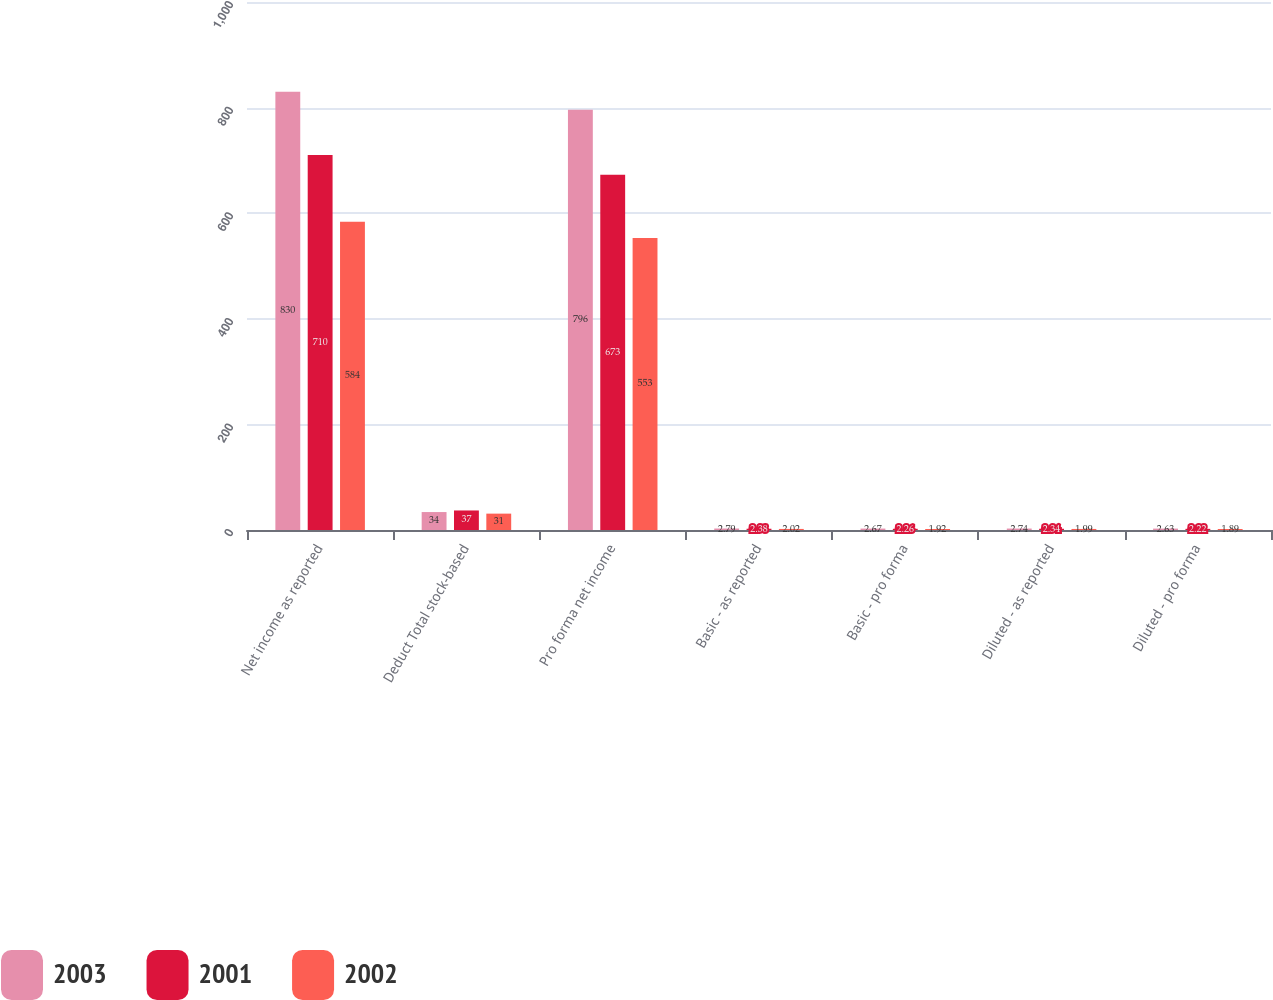Convert chart to OTSL. <chart><loc_0><loc_0><loc_500><loc_500><stacked_bar_chart><ecel><fcel>Net income as reported<fcel>Deduct Total stock-based<fcel>Pro forma net income<fcel>Basic - as reported<fcel>Basic - pro forma<fcel>Diluted - as reported<fcel>Diluted - pro forma<nl><fcel>2003<fcel>830<fcel>34<fcel>796<fcel>2.79<fcel>2.67<fcel>2.74<fcel>2.63<nl><fcel>2001<fcel>710<fcel>37<fcel>673<fcel>2.38<fcel>2.26<fcel>2.34<fcel>2.22<nl><fcel>2002<fcel>584<fcel>31<fcel>553<fcel>2.02<fcel>1.92<fcel>1.99<fcel>1.89<nl></chart> 